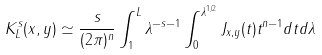<formula> <loc_0><loc_0><loc_500><loc_500>K ^ { s } _ { L } ( x , y ) \simeq \frac { s } { ( 2 \pi ) ^ { n } } \int _ { 1 } ^ { L } \lambda ^ { - s - 1 } \int _ { 0 } ^ { \lambda ^ { 1 / 2 } } J _ { x , y } ( t ) t ^ { n - 1 } d t d \lambda</formula> 